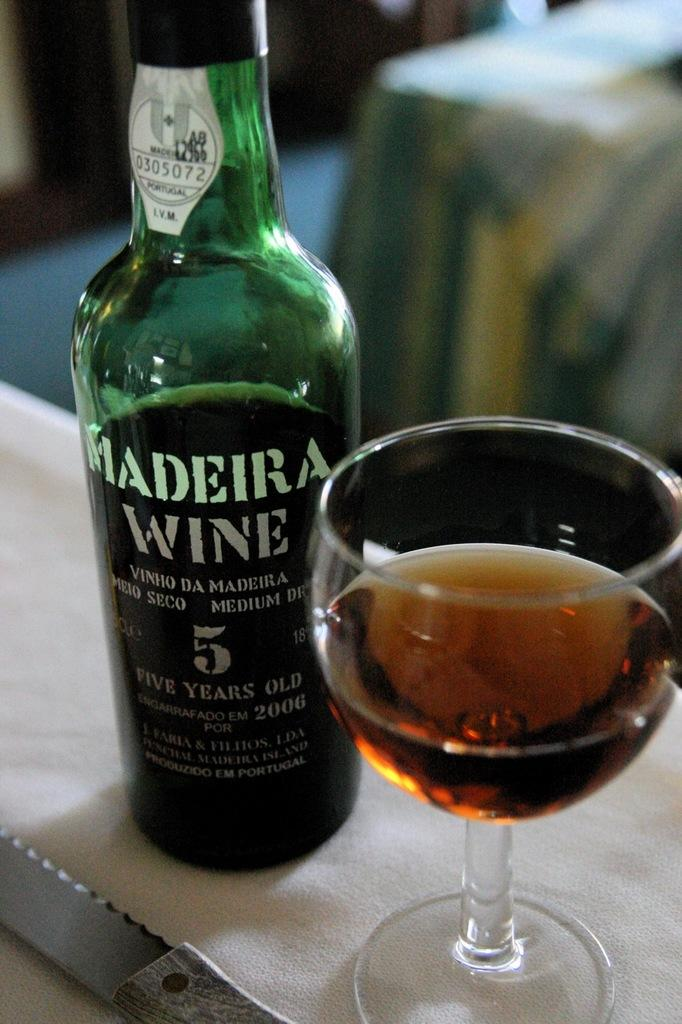What type of bottle can be seen in the image? There is a green color bottle in the image. What other objects are visible in the image? There is a knife and a glass in the image. Can you describe the background of the image? The background of the image is blurred. How many tickets are available for the event in the image? There is no event or tickets present in the image; it only features a green color bottle, a knife, a glass, and a blurred background. 